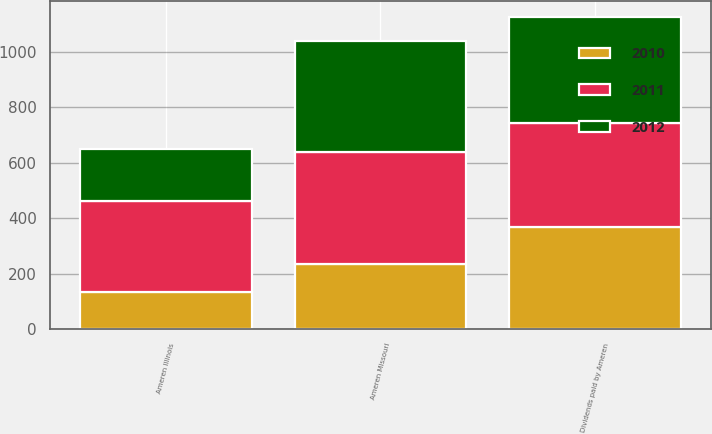Convert chart to OTSL. <chart><loc_0><loc_0><loc_500><loc_500><stacked_bar_chart><ecel><fcel>Ameren Missouri<fcel>Ameren Illinois<fcel>Dividends paid by Ameren<nl><fcel>2012<fcel>400<fcel>189<fcel>382<nl><fcel>2011<fcel>403<fcel>327<fcel>375<nl><fcel>2010<fcel>235<fcel>133<fcel>368<nl></chart> 